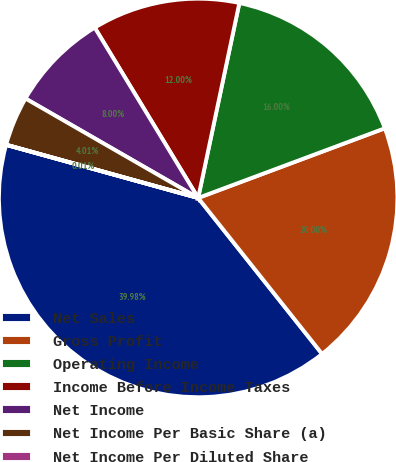Convert chart to OTSL. <chart><loc_0><loc_0><loc_500><loc_500><pie_chart><fcel>Net Sales<fcel>Gross Profit<fcel>Operating Income<fcel>Income Before Income Taxes<fcel>Net Income<fcel>Net Income Per Basic Share (a)<fcel>Net Income Per Diluted Share<nl><fcel>39.98%<fcel>20.0%<fcel>16.0%<fcel>12.0%<fcel>8.0%<fcel>4.01%<fcel>0.01%<nl></chart> 